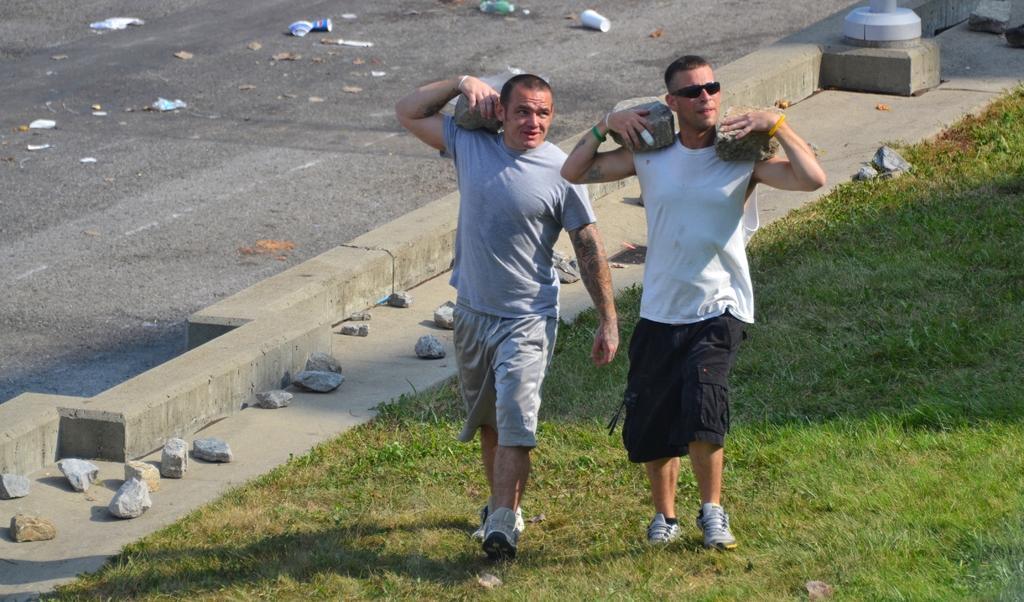Describe this image in one or two sentences. In this image there are two people walking by holding rocks on their shoulders, beside them there are stones on the pavement, beside the stones there is a concrete fence, on the other side of the fence there is trash on the road, behind them there is a concrete foundation with a pole on it. 